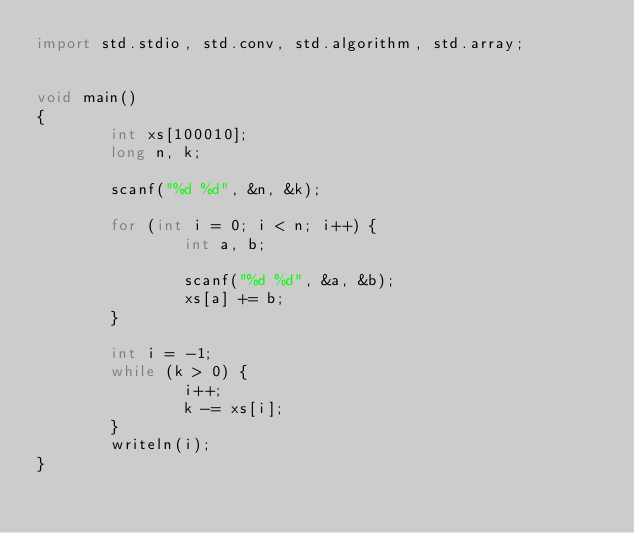Convert code to text. <code><loc_0><loc_0><loc_500><loc_500><_D_>import std.stdio, std.conv, std.algorithm, std.array;


void main()
{
        int xs[100010];
        long n, k;

        scanf("%d %d", &n, &k);

        for (int i = 0; i < n; i++) {
                int a, b;

                scanf("%d %d", &a, &b);
                xs[a] += b;
        }

        int i = -1;
        while (k > 0) {
                i++;
                k -= xs[i];
        }
        writeln(i);
}</code> 